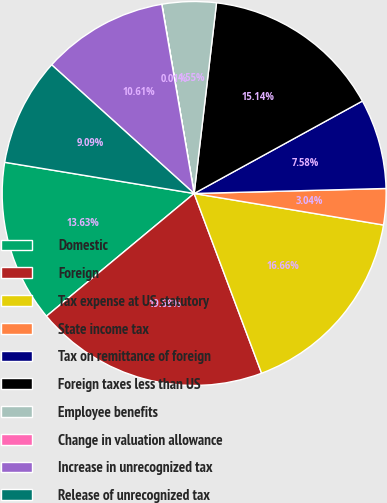<chart> <loc_0><loc_0><loc_500><loc_500><pie_chart><fcel>Domestic<fcel>Foreign<fcel>Tax expense at US statutory<fcel>State income tax<fcel>Tax on remittance of foreign<fcel>Foreign taxes less than US<fcel>Employee benefits<fcel>Change in valuation allowance<fcel>Increase in unrecognized tax<fcel>Release of unrecognized tax<nl><fcel>13.63%<fcel>19.68%<fcel>16.66%<fcel>3.04%<fcel>7.58%<fcel>15.14%<fcel>4.55%<fcel>0.01%<fcel>10.61%<fcel>9.09%<nl></chart> 